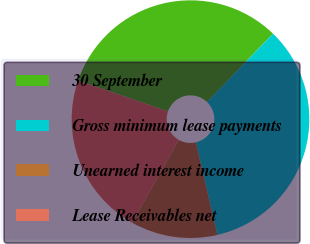Convert chart to OTSL. <chart><loc_0><loc_0><loc_500><loc_500><pie_chart><fcel>30 September<fcel>Gross minimum lease payments<fcel>Unearned interest income<fcel>Lease Receivables net<nl><fcel>31.95%<fcel>34.16%<fcel>11.81%<fcel>22.09%<nl></chart> 